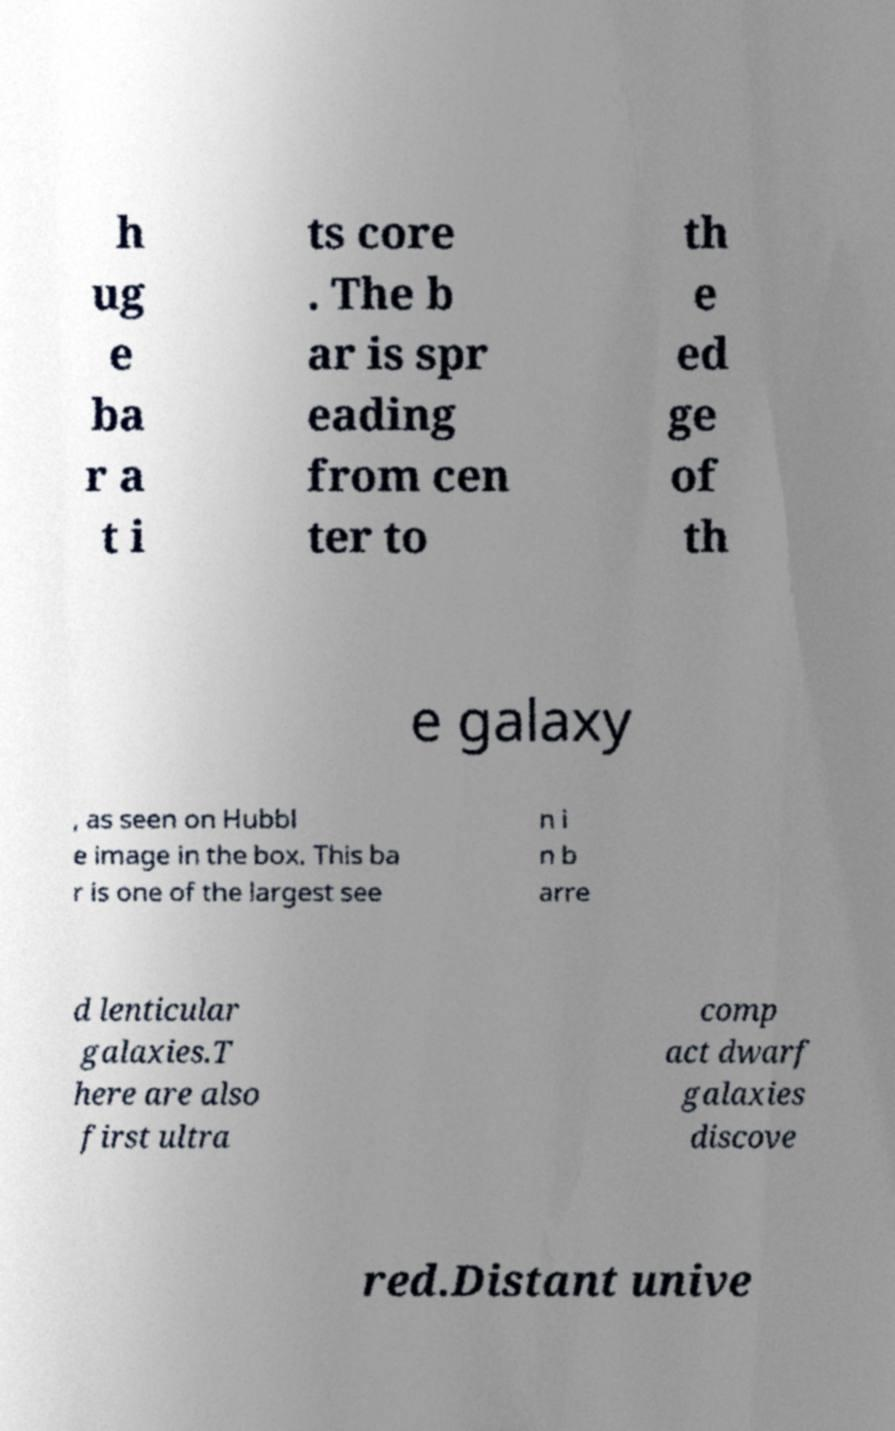I need the written content from this picture converted into text. Can you do that? h ug e ba r a t i ts core . The b ar is spr eading from cen ter to th e ed ge of th e galaxy , as seen on Hubbl e image in the box. This ba r is one of the largest see n i n b arre d lenticular galaxies.T here are also first ultra comp act dwarf galaxies discove red.Distant unive 